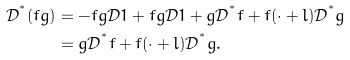<formula> <loc_0><loc_0><loc_500><loc_500>\mathcal { D } ^ { ^ { * } } ( f g ) & = - f g \mathcal { D } 1 + f g \mathcal { D } 1 + g \mathcal { D } ^ { ^ { * } } f + f ( \cdot + l ) \mathcal { D } ^ { ^ { * } } g \\ & = g \mathcal { D } ^ { ^ { * } } f + f ( \cdot + l ) \mathcal { D } ^ { ^ { * } } g .</formula> 